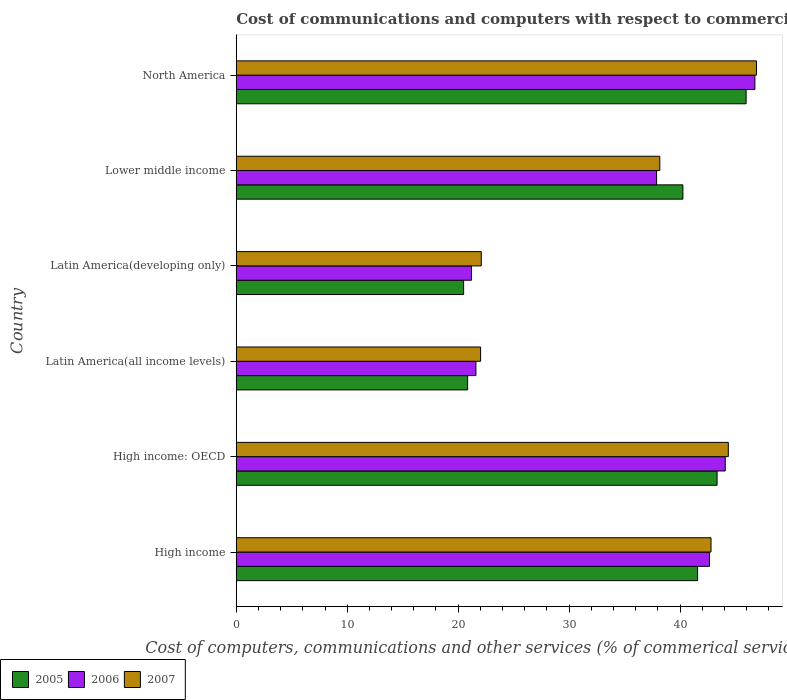How many groups of bars are there?
Keep it short and to the point. 6. In how many cases, is the number of bars for a given country not equal to the number of legend labels?
Offer a terse response. 0. What is the cost of communications and computers in 2005 in High income?
Provide a short and direct response. 41.58. Across all countries, what is the maximum cost of communications and computers in 2007?
Your response must be concise. 46.89. Across all countries, what is the minimum cost of communications and computers in 2007?
Make the answer very short. 22.02. In which country was the cost of communications and computers in 2006 maximum?
Your answer should be compact. North America. In which country was the cost of communications and computers in 2006 minimum?
Offer a very short reply. Latin America(developing only). What is the total cost of communications and computers in 2005 in the graph?
Your answer should be compact. 212.48. What is the difference between the cost of communications and computers in 2005 in Latin America(all income levels) and that in Lower middle income?
Your response must be concise. -19.4. What is the difference between the cost of communications and computers in 2007 in High income and the cost of communications and computers in 2005 in Latin America(all income levels)?
Offer a very short reply. 21.94. What is the average cost of communications and computers in 2005 per country?
Make the answer very short. 35.41. What is the difference between the cost of communications and computers in 2006 and cost of communications and computers in 2005 in Latin America(all income levels)?
Make the answer very short. 0.75. In how many countries, is the cost of communications and computers in 2006 greater than 38 %?
Ensure brevity in your answer.  3. What is the ratio of the cost of communications and computers in 2005 in High income to that in Latin America(all income levels)?
Your answer should be very brief. 1.99. Is the cost of communications and computers in 2007 in High income less than that in Latin America(all income levels)?
Your answer should be very brief. No. What is the difference between the highest and the second highest cost of communications and computers in 2006?
Your response must be concise. 2.67. What is the difference between the highest and the lowest cost of communications and computers in 2005?
Make the answer very short. 25.46. In how many countries, is the cost of communications and computers in 2005 greater than the average cost of communications and computers in 2005 taken over all countries?
Offer a terse response. 4. What does the 2nd bar from the top in Latin America(all income levels) represents?
Provide a short and direct response. 2006. What does the 2nd bar from the bottom in Lower middle income represents?
Your answer should be very brief. 2006. Is it the case that in every country, the sum of the cost of communications and computers in 2005 and cost of communications and computers in 2006 is greater than the cost of communications and computers in 2007?
Ensure brevity in your answer.  Yes. How many bars are there?
Provide a short and direct response. 18. Does the graph contain any zero values?
Give a very brief answer. No. What is the title of the graph?
Your answer should be compact. Cost of communications and computers with respect to commercial service exports. Does "1973" appear as one of the legend labels in the graph?
Your response must be concise. No. What is the label or title of the X-axis?
Give a very brief answer. Cost of computers, communications and other services (% of commerical service exports). What is the label or title of the Y-axis?
Your answer should be very brief. Country. What is the Cost of computers, communications and other services (% of commerical service exports) in 2005 in High income?
Your response must be concise. 41.58. What is the Cost of computers, communications and other services (% of commerical service exports) in 2006 in High income?
Provide a succinct answer. 42.66. What is the Cost of computers, communications and other services (% of commerical service exports) of 2007 in High income?
Provide a short and direct response. 42.79. What is the Cost of computers, communications and other services (% of commerical service exports) in 2005 in High income: OECD?
Provide a short and direct response. 43.34. What is the Cost of computers, communications and other services (% of commerical service exports) of 2006 in High income: OECD?
Offer a terse response. 44.07. What is the Cost of computers, communications and other services (% of commerical service exports) in 2007 in High income: OECD?
Provide a short and direct response. 44.35. What is the Cost of computers, communications and other services (% of commerical service exports) of 2005 in Latin America(all income levels)?
Make the answer very short. 20.86. What is the Cost of computers, communications and other services (% of commerical service exports) of 2006 in Latin America(all income levels)?
Keep it short and to the point. 21.6. What is the Cost of computers, communications and other services (% of commerical service exports) in 2007 in Latin America(all income levels)?
Provide a succinct answer. 22.02. What is the Cost of computers, communications and other services (% of commerical service exports) in 2005 in Latin America(developing only)?
Ensure brevity in your answer.  20.49. What is the Cost of computers, communications and other services (% of commerical service exports) of 2006 in Latin America(developing only)?
Offer a very short reply. 21.21. What is the Cost of computers, communications and other services (% of commerical service exports) in 2007 in Latin America(developing only)?
Your answer should be compact. 22.09. What is the Cost of computers, communications and other services (% of commerical service exports) in 2005 in Lower middle income?
Give a very brief answer. 40.26. What is the Cost of computers, communications and other services (% of commerical service exports) of 2006 in Lower middle income?
Make the answer very short. 37.89. What is the Cost of computers, communications and other services (% of commerical service exports) of 2007 in Lower middle income?
Ensure brevity in your answer.  38.18. What is the Cost of computers, communications and other services (% of commerical service exports) of 2005 in North America?
Your answer should be compact. 45.96. What is the Cost of computers, communications and other services (% of commerical service exports) of 2006 in North America?
Your answer should be compact. 46.75. What is the Cost of computers, communications and other services (% of commerical service exports) in 2007 in North America?
Your response must be concise. 46.89. Across all countries, what is the maximum Cost of computers, communications and other services (% of commerical service exports) in 2005?
Ensure brevity in your answer.  45.96. Across all countries, what is the maximum Cost of computers, communications and other services (% of commerical service exports) of 2006?
Keep it short and to the point. 46.75. Across all countries, what is the maximum Cost of computers, communications and other services (% of commerical service exports) in 2007?
Give a very brief answer. 46.89. Across all countries, what is the minimum Cost of computers, communications and other services (% of commerical service exports) in 2005?
Your answer should be very brief. 20.49. Across all countries, what is the minimum Cost of computers, communications and other services (% of commerical service exports) in 2006?
Ensure brevity in your answer.  21.21. Across all countries, what is the minimum Cost of computers, communications and other services (% of commerical service exports) of 2007?
Your response must be concise. 22.02. What is the total Cost of computers, communications and other services (% of commerical service exports) in 2005 in the graph?
Your answer should be compact. 212.48. What is the total Cost of computers, communications and other services (% of commerical service exports) of 2006 in the graph?
Make the answer very short. 214.17. What is the total Cost of computers, communications and other services (% of commerical service exports) in 2007 in the graph?
Your response must be concise. 216.32. What is the difference between the Cost of computers, communications and other services (% of commerical service exports) of 2005 in High income and that in High income: OECD?
Provide a short and direct response. -1.76. What is the difference between the Cost of computers, communications and other services (% of commerical service exports) in 2006 in High income and that in High income: OECD?
Your response must be concise. -1.42. What is the difference between the Cost of computers, communications and other services (% of commerical service exports) of 2007 in High income and that in High income: OECD?
Your response must be concise. -1.56. What is the difference between the Cost of computers, communications and other services (% of commerical service exports) of 2005 in High income and that in Latin America(all income levels)?
Provide a short and direct response. 20.73. What is the difference between the Cost of computers, communications and other services (% of commerical service exports) of 2006 in High income and that in Latin America(all income levels)?
Offer a terse response. 21.05. What is the difference between the Cost of computers, communications and other services (% of commerical service exports) of 2007 in High income and that in Latin America(all income levels)?
Keep it short and to the point. 20.77. What is the difference between the Cost of computers, communications and other services (% of commerical service exports) of 2005 in High income and that in Latin America(developing only)?
Offer a very short reply. 21.09. What is the difference between the Cost of computers, communications and other services (% of commerical service exports) in 2006 in High income and that in Latin America(developing only)?
Your answer should be compact. 21.45. What is the difference between the Cost of computers, communications and other services (% of commerical service exports) in 2007 in High income and that in Latin America(developing only)?
Keep it short and to the point. 20.71. What is the difference between the Cost of computers, communications and other services (% of commerical service exports) in 2005 in High income and that in Lower middle income?
Provide a short and direct response. 1.32. What is the difference between the Cost of computers, communications and other services (% of commerical service exports) of 2006 in High income and that in Lower middle income?
Offer a terse response. 4.77. What is the difference between the Cost of computers, communications and other services (% of commerical service exports) of 2007 in High income and that in Lower middle income?
Your answer should be very brief. 4.62. What is the difference between the Cost of computers, communications and other services (% of commerical service exports) in 2005 in High income and that in North America?
Your answer should be very brief. -4.37. What is the difference between the Cost of computers, communications and other services (% of commerical service exports) in 2006 in High income and that in North America?
Your answer should be compact. -4.09. What is the difference between the Cost of computers, communications and other services (% of commerical service exports) in 2007 in High income and that in North America?
Your answer should be very brief. -4.1. What is the difference between the Cost of computers, communications and other services (% of commerical service exports) of 2005 in High income: OECD and that in Latin America(all income levels)?
Your answer should be very brief. 22.48. What is the difference between the Cost of computers, communications and other services (% of commerical service exports) of 2006 in High income: OECD and that in Latin America(all income levels)?
Your response must be concise. 22.47. What is the difference between the Cost of computers, communications and other services (% of commerical service exports) of 2007 in High income: OECD and that in Latin America(all income levels)?
Give a very brief answer. 22.33. What is the difference between the Cost of computers, communications and other services (% of commerical service exports) in 2005 in High income: OECD and that in Latin America(developing only)?
Your answer should be compact. 22.84. What is the difference between the Cost of computers, communications and other services (% of commerical service exports) of 2006 in High income: OECD and that in Latin America(developing only)?
Provide a succinct answer. 22.87. What is the difference between the Cost of computers, communications and other services (% of commerical service exports) of 2007 in High income: OECD and that in Latin America(developing only)?
Your answer should be compact. 22.27. What is the difference between the Cost of computers, communications and other services (% of commerical service exports) of 2005 in High income: OECD and that in Lower middle income?
Give a very brief answer. 3.08. What is the difference between the Cost of computers, communications and other services (% of commerical service exports) in 2006 in High income: OECD and that in Lower middle income?
Ensure brevity in your answer.  6.19. What is the difference between the Cost of computers, communications and other services (% of commerical service exports) of 2007 in High income: OECD and that in Lower middle income?
Keep it short and to the point. 6.17. What is the difference between the Cost of computers, communications and other services (% of commerical service exports) in 2005 in High income: OECD and that in North America?
Your answer should be very brief. -2.62. What is the difference between the Cost of computers, communications and other services (% of commerical service exports) of 2006 in High income: OECD and that in North America?
Ensure brevity in your answer.  -2.67. What is the difference between the Cost of computers, communications and other services (% of commerical service exports) in 2007 in High income: OECD and that in North America?
Give a very brief answer. -2.54. What is the difference between the Cost of computers, communications and other services (% of commerical service exports) in 2005 in Latin America(all income levels) and that in Latin America(developing only)?
Provide a succinct answer. 0.36. What is the difference between the Cost of computers, communications and other services (% of commerical service exports) of 2006 in Latin America(all income levels) and that in Latin America(developing only)?
Give a very brief answer. 0.4. What is the difference between the Cost of computers, communications and other services (% of commerical service exports) of 2007 in Latin America(all income levels) and that in Latin America(developing only)?
Offer a terse response. -0.06. What is the difference between the Cost of computers, communications and other services (% of commerical service exports) of 2005 in Latin America(all income levels) and that in Lower middle income?
Make the answer very short. -19.4. What is the difference between the Cost of computers, communications and other services (% of commerical service exports) of 2006 in Latin America(all income levels) and that in Lower middle income?
Offer a terse response. -16.28. What is the difference between the Cost of computers, communications and other services (% of commerical service exports) of 2007 in Latin America(all income levels) and that in Lower middle income?
Give a very brief answer. -16.15. What is the difference between the Cost of computers, communications and other services (% of commerical service exports) in 2005 in Latin America(all income levels) and that in North America?
Offer a terse response. -25.1. What is the difference between the Cost of computers, communications and other services (% of commerical service exports) of 2006 in Latin America(all income levels) and that in North America?
Make the answer very short. -25.14. What is the difference between the Cost of computers, communications and other services (% of commerical service exports) of 2007 in Latin America(all income levels) and that in North America?
Provide a succinct answer. -24.87. What is the difference between the Cost of computers, communications and other services (% of commerical service exports) in 2005 in Latin America(developing only) and that in Lower middle income?
Keep it short and to the point. -19.76. What is the difference between the Cost of computers, communications and other services (% of commerical service exports) in 2006 in Latin America(developing only) and that in Lower middle income?
Offer a terse response. -16.68. What is the difference between the Cost of computers, communications and other services (% of commerical service exports) in 2007 in Latin America(developing only) and that in Lower middle income?
Provide a short and direct response. -16.09. What is the difference between the Cost of computers, communications and other services (% of commerical service exports) of 2005 in Latin America(developing only) and that in North America?
Ensure brevity in your answer.  -25.46. What is the difference between the Cost of computers, communications and other services (% of commerical service exports) in 2006 in Latin America(developing only) and that in North America?
Keep it short and to the point. -25.54. What is the difference between the Cost of computers, communications and other services (% of commerical service exports) in 2007 in Latin America(developing only) and that in North America?
Keep it short and to the point. -24.8. What is the difference between the Cost of computers, communications and other services (% of commerical service exports) of 2005 in Lower middle income and that in North America?
Provide a short and direct response. -5.7. What is the difference between the Cost of computers, communications and other services (% of commerical service exports) in 2006 in Lower middle income and that in North America?
Offer a very short reply. -8.86. What is the difference between the Cost of computers, communications and other services (% of commerical service exports) in 2007 in Lower middle income and that in North America?
Your answer should be very brief. -8.71. What is the difference between the Cost of computers, communications and other services (% of commerical service exports) of 2005 in High income and the Cost of computers, communications and other services (% of commerical service exports) of 2006 in High income: OECD?
Keep it short and to the point. -2.49. What is the difference between the Cost of computers, communications and other services (% of commerical service exports) of 2005 in High income and the Cost of computers, communications and other services (% of commerical service exports) of 2007 in High income: OECD?
Provide a short and direct response. -2.77. What is the difference between the Cost of computers, communications and other services (% of commerical service exports) in 2006 in High income and the Cost of computers, communications and other services (% of commerical service exports) in 2007 in High income: OECD?
Offer a very short reply. -1.7. What is the difference between the Cost of computers, communications and other services (% of commerical service exports) of 2005 in High income and the Cost of computers, communications and other services (% of commerical service exports) of 2006 in Latin America(all income levels)?
Your response must be concise. 19.98. What is the difference between the Cost of computers, communications and other services (% of commerical service exports) of 2005 in High income and the Cost of computers, communications and other services (% of commerical service exports) of 2007 in Latin America(all income levels)?
Your answer should be compact. 19.56. What is the difference between the Cost of computers, communications and other services (% of commerical service exports) in 2006 in High income and the Cost of computers, communications and other services (% of commerical service exports) in 2007 in Latin America(all income levels)?
Make the answer very short. 20.63. What is the difference between the Cost of computers, communications and other services (% of commerical service exports) of 2005 in High income and the Cost of computers, communications and other services (% of commerical service exports) of 2006 in Latin America(developing only)?
Make the answer very short. 20.38. What is the difference between the Cost of computers, communications and other services (% of commerical service exports) of 2005 in High income and the Cost of computers, communications and other services (% of commerical service exports) of 2007 in Latin America(developing only)?
Keep it short and to the point. 19.5. What is the difference between the Cost of computers, communications and other services (% of commerical service exports) in 2006 in High income and the Cost of computers, communications and other services (% of commerical service exports) in 2007 in Latin America(developing only)?
Your response must be concise. 20.57. What is the difference between the Cost of computers, communications and other services (% of commerical service exports) of 2005 in High income and the Cost of computers, communications and other services (% of commerical service exports) of 2006 in Lower middle income?
Make the answer very short. 3.7. What is the difference between the Cost of computers, communications and other services (% of commerical service exports) in 2005 in High income and the Cost of computers, communications and other services (% of commerical service exports) in 2007 in Lower middle income?
Your answer should be compact. 3.41. What is the difference between the Cost of computers, communications and other services (% of commerical service exports) in 2006 in High income and the Cost of computers, communications and other services (% of commerical service exports) in 2007 in Lower middle income?
Your response must be concise. 4.48. What is the difference between the Cost of computers, communications and other services (% of commerical service exports) in 2005 in High income and the Cost of computers, communications and other services (% of commerical service exports) in 2006 in North America?
Ensure brevity in your answer.  -5.16. What is the difference between the Cost of computers, communications and other services (% of commerical service exports) in 2005 in High income and the Cost of computers, communications and other services (% of commerical service exports) in 2007 in North America?
Keep it short and to the point. -5.31. What is the difference between the Cost of computers, communications and other services (% of commerical service exports) of 2006 in High income and the Cost of computers, communications and other services (% of commerical service exports) of 2007 in North America?
Give a very brief answer. -4.23. What is the difference between the Cost of computers, communications and other services (% of commerical service exports) in 2005 in High income: OECD and the Cost of computers, communications and other services (% of commerical service exports) in 2006 in Latin America(all income levels)?
Your response must be concise. 21.74. What is the difference between the Cost of computers, communications and other services (% of commerical service exports) in 2005 in High income: OECD and the Cost of computers, communications and other services (% of commerical service exports) in 2007 in Latin America(all income levels)?
Keep it short and to the point. 21.31. What is the difference between the Cost of computers, communications and other services (% of commerical service exports) of 2006 in High income: OECD and the Cost of computers, communications and other services (% of commerical service exports) of 2007 in Latin America(all income levels)?
Your answer should be compact. 22.05. What is the difference between the Cost of computers, communications and other services (% of commerical service exports) in 2005 in High income: OECD and the Cost of computers, communications and other services (% of commerical service exports) in 2006 in Latin America(developing only)?
Offer a very short reply. 22.13. What is the difference between the Cost of computers, communications and other services (% of commerical service exports) of 2005 in High income: OECD and the Cost of computers, communications and other services (% of commerical service exports) of 2007 in Latin America(developing only)?
Provide a short and direct response. 21.25. What is the difference between the Cost of computers, communications and other services (% of commerical service exports) of 2006 in High income: OECD and the Cost of computers, communications and other services (% of commerical service exports) of 2007 in Latin America(developing only)?
Your answer should be very brief. 21.99. What is the difference between the Cost of computers, communications and other services (% of commerical service exports) in 2005 in High income: OECD and the Cost of computers, communications and other services (% of commerical service exports) in 2006 in Lower middle income?
Make the answer very short. 5.45. What is the difference between the Cost of computers, communications and other services (% of commerical service exports) of 2005 in High income: OECD and the Cost of computers, communications and other services (% of commerical service exports) of 2007 in Lower middle income?
Ensure brevity in your answer.  5.16. What is the difference between the Cost of computers, communications and other services (% of commerical service exports) of 2006 in High income: OECD and the Cost of computers, communications and other services (% of commerical service exports) of 2007 in Lower middle income?
Your answer should be very brief. 5.9. What is the difference between the Cost of computers, communications and other services (% of commerical service exports) in 2005 in High income: OECD and the Cost of computers, communications and other services (% of commerical service exports) in 2006 in North America?
Keep it short and to the point. -3.41. What is the difference between the Cost of computers, communications and other services (% of commerical service exports) in 2005 in High income: OECD and the Cost of computers, communications and other services (% of commerical service exports) in 2007 in North America?
Ensure brevity in your answer.  -3.55. What is the difference between the Cost of computers, communications and other services (% of commerical service exports) in 2006 in High income: OECD and the Cost of computers, communications and other services (% of commerical service exports) in 2007 in North America?
Give a very brief answer. -2.82. What is the difference between the Cost of computers, communications and other services (% of commerical service exports) in 2005 in Latin America(all income levels) and the Cost of computers, communications and other services (% of commerical service exports) in 2006 in Latin America(developing only)?
Make the answer very short. -0.35. What is the difference between the Cost of computers, communications and other services (% of commerical service exports) in 2005 in Latin America(all income levels) and the Cost of computers, communications and other services (% of commerical service exports) in 2007 in Latin America(developing only)?
Keep it short and to the point. -1.23. What is the difference between the Cost of computers, communications and other services (% of commerical service exports) in 2006 in Latin America(all income levels) and the Cost of computers, communications and other services (% of commerical service exports) in 2007 in Latin America(developing only)?
Your answer should be very brief. -0.48. What is the difference between the Cost of computers, communications and other services (% of commerical service exports) of 2005 in Latin America(all income levels) and the Cost of computers, communications and other services (% of commerical service exports) of 2006 in Lower middle income?
Make the answer very short. -17.03. What is the difference between the Cost of computers, communications and other services (% of commerical service exports) in 2005 in Latin America(all income levels) and the Cost of computers, communications and other services (% of commerical service exports) in 2007 in Lower middle income?
Give a very brief answer. -17.32. What is the difference between the Cost of computers, communications and other services (% of commerical service exports) of 2006 in Latin America(all income levels) and the Cost of computers, communications and other services (% of commerical service exports) of 2007 in Lower middle income?
Give a very brief answer. -16.57. What is the difference between the Cost of computers, communications and other services (% of commerical service exports) of 2005 in Latin America(all income levels) and the Cost of computers, communications and other services (% of commerical service exports) of 2006 in North America?
Make the answer very short. -25.89. What is the difference between the Cost of computers, communications and other services (% of commerical service exports) of 2005 in Latin America(all income levels) and the Cost of computers, communications and other services (% of commerical service exports) of 2007 in North America?
Keep it short and to the point. -26.03. What is the difference between the Cost of computers, communications and other services (% of commerical service exports) in 2006 in Latin America(all income levels) and the Cost of computers, communications and other services (% of commerical service exports) in 2007 in North America?
Offer a very short reply. -25.29. What is the difference between the Cost of computers, communications and other services (% of commerical service exports) in 2005 in Latin America(developing only) and the Cost of computers, communications and other services (% of commerical service exports) in 2006 in Lower middle income?
Offer a very short reply. -17.39. What is the difference between the Cost of computers, communications and other services (% of commerical service exports) of 2005 in Latin America(developing only) and the Cost of computers, communications and other services (% of commerical service exports) of 2007 in Lower middle income?
Your answer should be compact. -17.68. What is the difference between the Cost of computers, communications and other services (% of commerical service exports) in 2006 in Latin America(developing only) and the Cost of computers, communications and other services (% of commerical service exports) in 2007 in Lower middle income?
Provide a succinct answer. -16.97. What is the difference between the Cost of computers, communications and other services (% of commerical service exports) in 2005 in Latin America(developing only) and the Cost of computers, communications and other services (% of commerical service exports) in 2006 in North America?
Your answer should be compact. -26.25. What is the difference between the Cost of computers, communications and other services (% of commerical service exports) of 2005 in Latin America(developing only) and the Cost of computers, communications and other services (% of commerical service exports) of 2007 in North America?
Offer a terse response. -26.4. What is the difference between the Cost of computers, communications and other services (% of commerical service exports) in 2006 in Latin America(developing only) and the Cost of computers, communications and other services (% of commerical service exports) in 2007 in North America?
Keep it short and to the point. -25.68. What is the difference between the Cost of computers, communications and other services (% of commerical service exports) of 2005 in Lower middle income and the Cost of computers, communications and other services (% of commerical service exports) of 2006 in North America?
Give a very brief answer. -6.49. What is the difference between the Cost of computers, communications and other services (% of commerical service exports) of 2005 in Lower middle income and the Cost of computers, communications and other services (% of commerical service exports) of 2007 in North America?
Ensure brevity in your answer.  -6.63. What is the difference between the Cost of computers, communications and other services (% of commerical service exports) in 2006 in Lower middle income and the Cost of computers, communications and other services (% of commerical service exports) in 2007 in North America?
Provide a succinct answer. -9. What is the average Cost of computers, communications and other services (% of commerical service exports) of 2005 per country?
Provide a short and direct response. 35.41. What is the average Cost of computers, communications and other services (% of commerical service exports) in 2006 per country?
Offer a terse response. 35.69. What is the average Cost of computers, communications and other services (% of commerical service exports) in 2007 per country?
Your answer should be very brief. 36.05. What is the difference between the Cost of computers, communications and other services (% of commerical service exports) of 2005 and Cost of computers, communications and other services (% of commerical service exports) of 2006 in High income?
Your answer should be compact. -1.07. What is the difference between the Cost of computers, communications and other services (% of commerical service exports) of 2005 and Cost of computers, communications and other services (% of commerical service exports) of 2007 in High income?
Make the answer very short. -1.21. What is the difference between the Cost of computers, communications and other services (% of commerical service exports) of 2006 and Cost of computers, communications and other services (% of commerical service exports) of 2007 in High income?
Ensure brevity in your answer.  -0.14. What is the difference between the Cost of computers, communications and other services (% of commerical service exports) in 2005 and Cost of computers, communications and other services (% of commerical service exports) in 2006 in High income: OECD?
Provide a succinct answer. -0.74. What is the difference between the Cost of computers, communications and other services (% of commerical service exports) in 2005 and Cost of computers, communications and other services (% of commerical service exports) in 2007 in High income: OECD?
Provide a succinct answer. -1.01. What is the difference between the Cost of computers, communications and other services (% of commerical service exports) in 2006 and Cost of computers, communications and other services (% of commerical service exports) in 2007 in High income: OECD?
Make the answer very short. -0.28. What is the difference between the Cost of computers, communications and other services (% of commerical service exports) of 2005 and Cost of computers, communications and other services (% of commerical service exports) of 2006 in Latin America(all income levels)?
Ensure brevity in your answer.  -0.75. What is the difference between the Cost of computers, communications and other services (% of commerical service exports) of 2005 and Cost of computers, communications and other services (% of commerical service exports) of 2007 in Latin America(all income levels)?
Your answer should be compact. -1.17. What is the difference between the Cost of computers, communications and other services (% of commerical service exports) of 2006 and Cost of computers, communications and other services (% of commerical service exports) of 2007 in Latin America(all income levels)?
Provide a short and direct response. -0.42. What is the difference between the Cost of computers, communications and other services (% of commerical service exports) of 2005 and Cost of computers, communications and other services (% of commerical service exports) of 2006 in Latin America(developing only)?
Make the answer very short. -0.71. What is the difference between the Cost of computers, communications and other services (% of commerical service exports) of 2005 and Cost of computers, communications and other services (% of commerical service exports) of 2007 in Latin America(developing only)?
Offer a terse response. -1.59. What is the difference between the Cost of computers, communications and other services (% of commerical service exports) in 2006 and Cost of computers, communications and other services (% of commerical service exports) in 2007 in Latin America(developing only)?
Provide a short and direct response. -0.88. What is the difference between the Cost of computers, communications and other services (% of commerical service exports) of 2005 and Cost of computers, communications and other services (% of commerical service exports) of 2006 in Lower middle income?
Your answer should be compact. 2.37. What is the difference between the Cost of computers, communications and other services (% of commerical service exports) in 2005 and Cost of computers, communications and other services (% of commerical service exports) in 2007 in Lower middle income?
Make the answer very short. 2.08. What is the difference between the Cost of computers, communications and other services (% of commerical service exports) of 2006 and Cost of computers, communications and other services (% of commerical service exports) of 2007 in Lower middle income?
Your answer should be compact. -0.29. What is the difference between the Cost of computers, communications and other services (% of commerical service exports) in 2005 and Cost of computers, communications and other services (% of commerical service exports) in 2006 in North America?
Keep it short and to the point. -0.79. What is the difference between the Cost of computers, communications and other services (% of commerical service exports) of 2005 and Cost of computers, communications and other services (% of commerical service exports) of 2007 in North America?
Provide a succinct answer. -0.93. What is the difference between the Cost of computers, communications and other services (% of commerical service exports) in 2006 and Cost of computers, communications and other services (% of commerical service exports) in 2007 in North America?
Provide a succinct answer. -0.14. What is the ratio of the Cost of computers, communications and other services (% of commerical service exports) of 2005 in High income to that in High income: OECD?
Give a very brief answer. 0.96. What is the ratio of the Cost of computers, communications and other services (% of commerical service exports) in 2006 in High income to that in High income: OECD?
Your response must be concise. 0.97. What is the ratio of the Cost of computers, communications and other services (% of commerical service exports) of 2007 in High income to that in High income: OECD?
Your response must be concise. 0.96. What is the ratio of the Cost of computers, communications and other services (% of commerical service exports) in 2005 in High income to that in Latin America(all income levels)?
Keep it short and to the point. 1.99. What is the ratio of the Cost of computers, communications and other services (% of commerical service exports) in 2006 in High income to that in Latin America(all income levels)?
Make the answer very short. 1.97. What is the ratio of the Cost of computers, communications and other services (% of commerical service exports) in 2007 in High income to that in Latin America(all income levels)?
Your answer should be compact. 1.94. What is the ratio of the Cost of computers, communications and other services (% of commerical service exports) of 2005 in High income to that in Latin America(developing only)?
Provide a succinct answer. 2.03. What is the ratio of the Cost of computers, communications and other services (% of commerical service exports) of 2006 in High income to that in Latin America(developing only)?
Make the answer very short. 2.01. What is the ratio of the Cost of computers, communications and other services (% of commerical service exports) in 2007 in High income to that in Latin America(developing only)?
Provide a succinct answer. 1.94. What is the ratio of the Cost of computers, communications and other services (% of commerical service exports) of 2005 in High income to that in Lower middle income?
Offer a terse response. 1.03. What is the ratio of the Cost of computers, communications and other services (% of commerical service exports) in 2006 in High income to that in Lower middle income?
Offer a very short reply. 1.13. What is the ratio of the Cost of computers, communications and other services (% of commerical service exports) in 2007 in High income to that in Lower middle income?
Keep it short and to the point. 1.12. What is the ratio of the Cost of computers, communications and other services (% of commerical service exports) in 2005 in High income to that in North America?
Provide a succinct answer. 0.9. What is the ratio of the Cost of computers, communications and other services (% of commerical service exports) in 2006 in High income to that in North America?
Provide a succinct answer. 0.91. What is the ratio of the Cost of computers, communications and other services (% of commerical service exports) in 2007 in High income to that in North America?
Offer a very short reply. 0.91. What is the ratio of the Cost of computers, communications and other services (% of commerical service exports) of 2005 in High income: OECD to that in Latin America(all income levels)?
Make the answer very short. 2.08. What is the ratio of the Cost of computers, communications and other services (% of commerical service exports) of 2006 in High income: OECD to that in Latin America(all income levels)?
Give a very brief answer. 2.04. What is the ratio of the Cost of computers, communications and other services (% of commerical service exports) in 2007 in High income: OECD to that in Latin America(all income levels)?
Keep it short and to the point. 2.01. What is the ratio of the Cost of computers, communications and other services (% of commerical service exports) of 2005 in High income: OECD to that in Latin America(developing only)?
Your answer should be very brief. 2.11. What is the ratio of the Cost of computers, communications and other services (% of commerical service exports) in 2006 in High income: OECD to that in Latin America(developing only)?
Your response must be concise. 2.08. What is the ratio of the Cost of computers, communications and other services (% of commerical service exports) of 2007 in High income: OECD to that in Latin America(developing only)?
Make the answer very short. 2.01. What is the ratio of the Cost of computers, communications and other services (% of commerical service exports) in 2005 in High income: OECD to that in Lower middle income?
Keep it short and to the point. 1.08. What is the ratio of the Cost of computers, communications and other services (% of commerical service exports) in 2006 in High income: OECD to that in Lower middle income?
Offer a terse response. 1.16. What is the ratio of the Cost of computers, communications and other services (% of commerical service exports) of 2007 in High income: OECD to that in Lower middle income?
Ensure brevity in your answer.  1.16. What is the ratio of the Cost of computers, communications and other services (% of commerical service exports) of 2005 in High income: OECD to that in North America?
Make the answer very short. 0.94. What is the ratio of the Cost of computers, communications and other services (% of commerical service exports) in 2006 in High income: OECD to that in North America?
Give a very brief answer. 0.94. What is the ratio of the Cost of computers, communications and other services (% of commerical service exports) of 2007 in High income: OECD to that in North America?
Provide a short and direct response. 0.95. What is the ratio of the Cost of computers, communications and other services (% of commerical service exports) of 2005 in Latin America(all income levels) to that in Latin America(developing only)?
Make the answer very short. 1.02. What is the ratio of the Cost of computers, communications and other services (% of commerical service exports) of 2006 in Latin America(all income levels) to that in Latin America(developing only)?
Your answer should be compact. 1.02. What is the ratio of the Cost of computers, communications and other services (% of commerical service exports) of 2005 in Latin America(all income levels) to that in Lower middle income?
Offer a very short reply. 0.52. What is the ratio of the Cost of computers, communications and other services (% of commerical service exports) of 2006 in Latin America(all income levels) to that in Lower middle income?
Give a very brief answer. 0.57. What is the ratio of the Cost of computers, communications and other services (% of commerical service exports) in 2007 in Latin America(all income levels) to that in Lower middle income?
Keep it short and to the point. 0.58. What is the ratio of the Cost of computers, communications and other services (% of commerical service exports) in 2005 in Latin America(all income levels) to that in North America?
Provide a succinct answer. 0.45. What is the ratio of the Cost of computers, communications and other services (% of commerical service exports) of 2006 in Latin America(all income levels) to that in North America?
Offer a terse response. 0.46. What is the ratio of the Cost of computers, communications and other services (% of commerical service exports) of 2007 in Latin America(all income levels) to that in North America?
Your response must be concise. 0.47. What is the ratio of the Cost of computers, communications and other services (% of commerical service exports) in 2005 in Latin America(developing only) to that in Lower middle income?
Give a very brief answer. 0.51. What is the ratio of the Cost of computers, communications and other services (% of commerical service exports) in 2006 in Latin America(developing only) to that in Lower middle income?
Keep it short and to the point. 0.56. What is the ratio of the Cost of computers, communications and other services (% of commerical service exports) of 2007 in Latin America(developing only) to that in Lower middle income?
Ensure brevity in your answer.  0.58. What is the ratio of the Cost of computers, communications and other services (% of commerical service exports) of 2005 in Latin America(developing only) to that in North America?
Offer a very short reply. 0.45. What is the ratio of the Cost of computers, communications and other services (% of commerical service exports) of 2006 in Latin America(developing only) to that in North America?
Give a very brief answer. 0.45. What is the ratio of the Cost of computers, communications and other services (% of commerical service exports) of 2007 in Latin America(developing only) to that in North America?
Your answer should be compact. 0.47. What is the ratio of the Cost of computers, communications and other services (% of commerical service exports) in 2005 in Lower middle income to that in North America?
Make the answer very short. 0.88. What is the ratio of the Cost of computers, communications and other services (% of commerical service exports) in 2006 in Lower middle income to that in North America?
Keep it short and to the point. 0.81. What is the ratio of the Cost of computers, communications and other services (% of commerical service exports) of 2007 in Lower middle income to that in North America?
Make the answer very short. 0.81. What is the difference between the highest and the second highest Cost of computers, communications and other services (% of commerical service exports) of 2005?
Your answer should be compact. 2.62. What is the difference between the highest and the second highest Cost of computers, communications and other services (% of commerical service exports) in 2006?
Offer a very short reply. 2.67. What is the difference between the highest and the second highest Cost of computers, communications and other services (% of commerical service exports) of 2007?
Keep it short and to the point. 2.54. What is the difference between the highest and the lowest Cost of computers, communications and other services (% of commerical service exports) of 2005?
Your response must be concise. 25.46. What is the difference between the highest and the lowest Cost of computers, communications and other services (% of commerical service exports) in 2006?
Provide a succinct answer. 25.54. What is the difference between the highest and the lowest Cost of computers, communications and other services (% of commerical service exports) of 2007?
Provide a short and direct response. 24.87. 